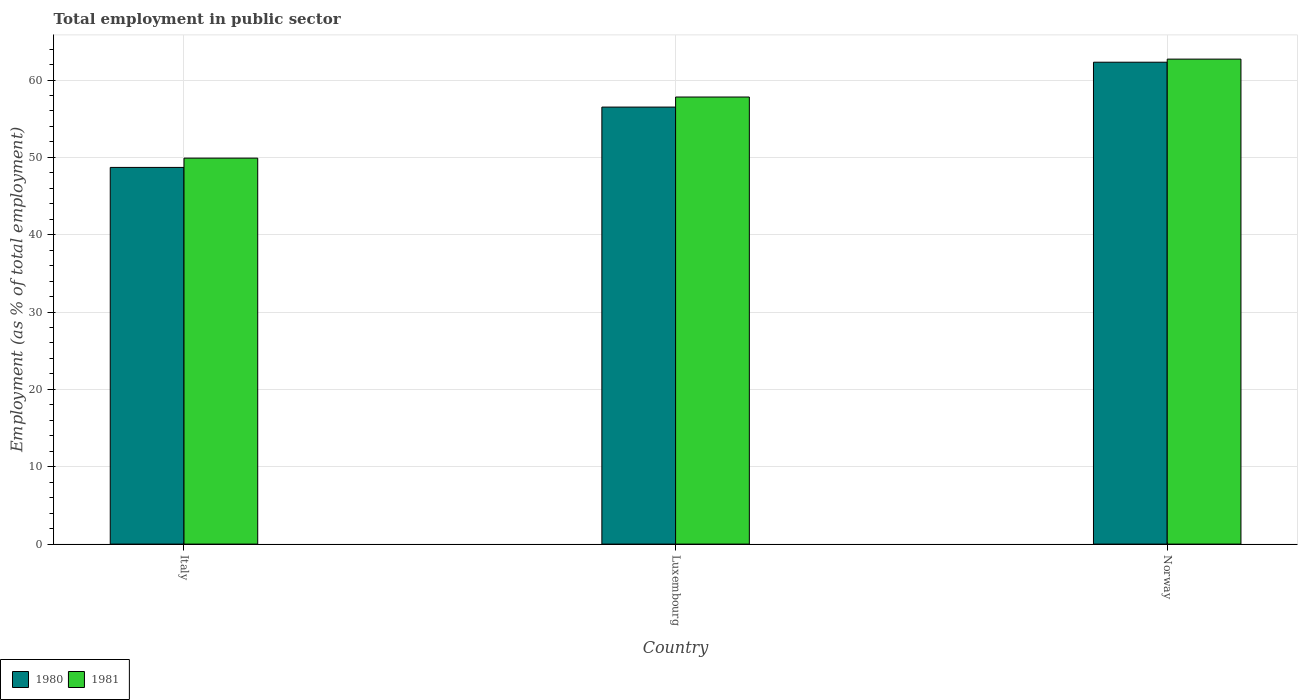How many groups of bars are there?
Offer a terse response. 3. What is the label of the 1st group of bars from the left?
Your response must be concise. Italy. In how many cases, is the number of bars for a given country not equal to the number of legend labels?
Offer a very short reply. 0. What is the employment in public sector in 1981 in Italy?
Offer a very short reply. 49.9. Across all countries, what is the maximum employment in public sector in 1980?
Your answer should be very brief. 62.3. Across all countries, what is the minimum employment in public sector in 1981?
Make the answer very short. 49.9. What is the total employment in public sector in 1981 in the graph?
Keep it short and to the point. 170.4. What is the difference between the employment in public sector in 1980 in Luxembourg and that in Norway?
Provide a short and direct response. -5.8. What is the difference between the employment in public sector in 1981 in Luxembourg and the employment in public sector in 1980 in Norway?
Offer a very short reply. -4.5. What is the average employment in public sector in 1981 per country?
Provide a succinct answer. 56.8. What is the difference between the employment in public sector of/in 1980 and employment in public sector of/in 1981 in Luxembourg?
Offer a very short reply. -1.3. What is the ratio of the employment in public sector in 1981 in Italy to that in Luxembourg?
Your answer should be compact. 0.86. Is the difference between the employment in public sector in 1980 in Luxembourg and Norway greater than the difference between the employment in public sector in 1981 in Luxembourg and Norway?
Your answer should be compact. No. What is the difference between the highest and the second highest employment in public sector in 1981?
Your answer should be compact. -4.9. What is the difference between the highest and the lowest employment in public sector in 1981?
Provide a short and direct response. 12.8. What does the 1st bar from the right in Italy represents?
Make the answer very short. 1981. Are all the bars in the graph horizontal?
Keep it short and to the point. No. How many countries are there in the graph?
Provide a short and direct response. 3. What is the difference between two consecutive major ticks on the Y-axis?
Offer a terse response. 10. How many legend labels are there?
Your response must be concise. 2. How are the legend labels stacked?
Provide a short and direct response. Horizontal. What is the title of the graph?
Offer a terse response. Total employment in public sector. What is the label or title of the Y-axis?
Your answer should be very brief. Employment (as % of total employment). What is the Employment (as % of total employment) of 1980 in Italy?
Make the answer very short. 48.7. What is the Employment (as % of total employment) in 1981 in Italy?
Ensure brevity in your answer.  49.9. What is the Employment (as % of total employment) of 1980 in Luxembourg?
Your answer should be compact. 56.5. What is the Employment (as % of total employment) of 1981 in Luxembourg?
Keep it short and to the point. 57.8. What is the Employment (as % of total employment) of 1980 in Norway?
Your response must be concise. 62.3. What is the Employment (as % of total employment) in 1981 in Norway?
Offer a terse response. 62.7. Across all countries, what is the maximum Employment (as % of total employment) in 1980?
Your answer should be compact. 62.3. Across all countries, what is the maximum Employment (as % of total employment) in 1981?
Keep it short and to the point. 62.7. Across all countries, what is the minimum Employment (as % of total employment) in 1980?
Offer a very short reply. 48.7. Across all countries, what is the minimum Employment (as % of total employment) of 1981?
Provide a succinct answer. 49.9. What is the total Employment (as % of total employment) in 1980 in the graph?
Make the answer very short. 167.5. What is the total Employment (as % of total employment) of 1981 in the graph?
Keep it short and to the point. 170.4. What is the difference between the Employment (as % of total employment) in 1980 in Italy and that in Luxembourg?
Offer a terse response. -7.8. What is the difference between the Employment (as % of total employment) in 1981 in Italy and that in Luxembourg?
Offer a terse response. -7.9. What is the difference between the Employment (as % of total employment) in 1980 in Italy and that in Norway?
Ensure brevity in your answer.  -13.6. What is the difference between the Employment (as % of total employment) in 1980 in Italy and the Employment (as % of total employment) in 1981 in Norway?
Give a very brief answer. -14. What is the difference between the Employment (as % of total employment) in 1980 in Luxembourg and the Employment (as % of total employment) in 1981 in Norway?
Ensure brevity in your answer.  -6.2. What is the average Employment (as % of total employment) in 1980 per country?
Keep it short and to the point. 55.83. What is the average Employment (as % of total employment) in 1981 per country?
Your answer should be very brief. 56.8. What is the ratio of the Employment (as % of total employment) in 1980 in Italy to that in Luxembourg?
Provide a short and direct response. 0.86. What is the ratio of the Employment (as % of total employment) in 1981 in Italy to that in Luxembourg?
Ensure brevity in your answer.  0.86. What is the ratio of the Employment (as % of total employment) in 1980 in Italy to that in Norway?
Your response must be concise. 0.78. What is the ratio of the Employment (as % of total employment) in 1981 in Italy to that in Norway?
Your answer should be very brief. 0.8. What is the ratio of the Employment (as % of total employment) of 1980 in Luxembourg to that in Norway?
Make the answer very short. 0.91. What is the ratio of the Employment (as % of total employment) in 1981 in Luxembourg to that in Norway?
Provide a short and direct response. 0.92. What is the difference between the highest and the second highest Employment (as % of total employment) of 1980?
Ensure brevity in your answer.  5.8. What is the difference between the highest and the lowest Employment (as % of total employment) of 1981?
Your answer should be compact. 12.8. 